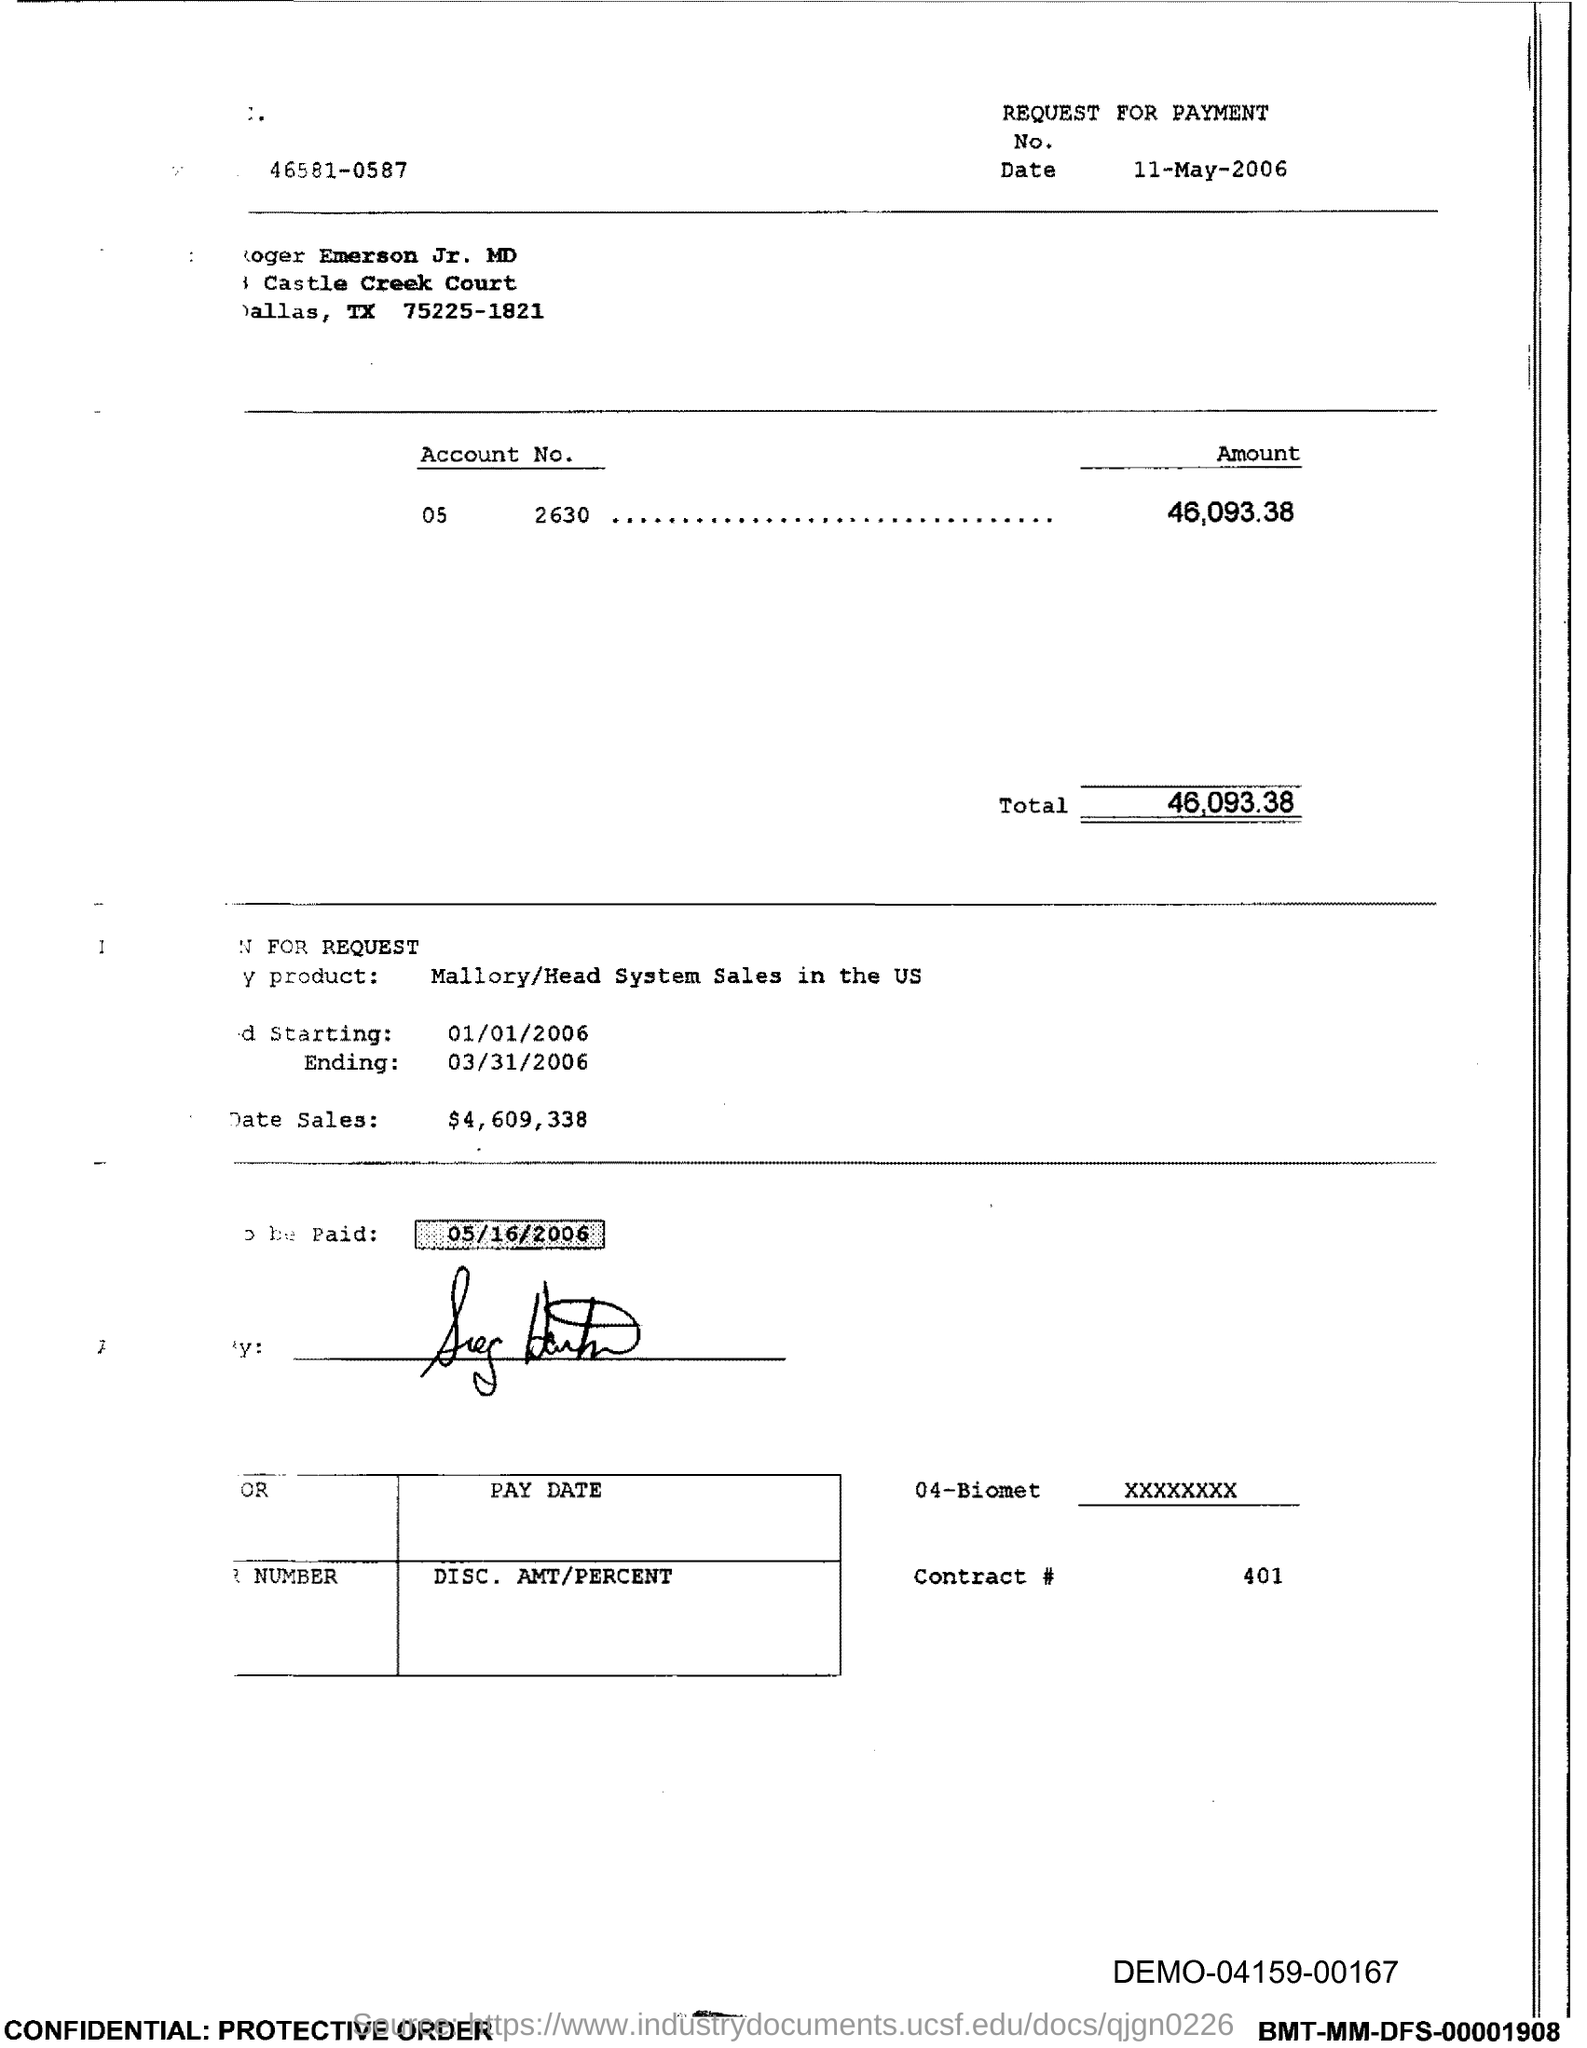Point out several critical features in this image. The total is 46,093.38. The document states that the amount is 46,093.38... 